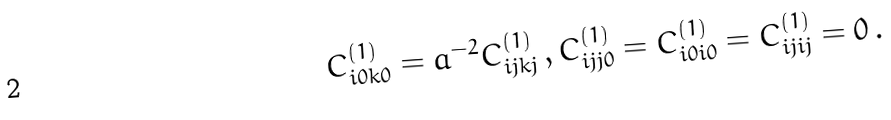Convert formula to latex. <formula><loc_0><loc_0><loc_500><loc_500>C ^ { ( 1 ) } _ { i 0 k 0 } = a ^ { - 2 } C ^ { ( 1 ) } _ { i j k j } \, , C ^ { ( 1 ) } _ { i j j 0 } = C ^ { ( 1 ) } _ { i 0 i 0 } = C ^ { ( 1 ) } _ { i j i j } = 0 \, .</formula> 